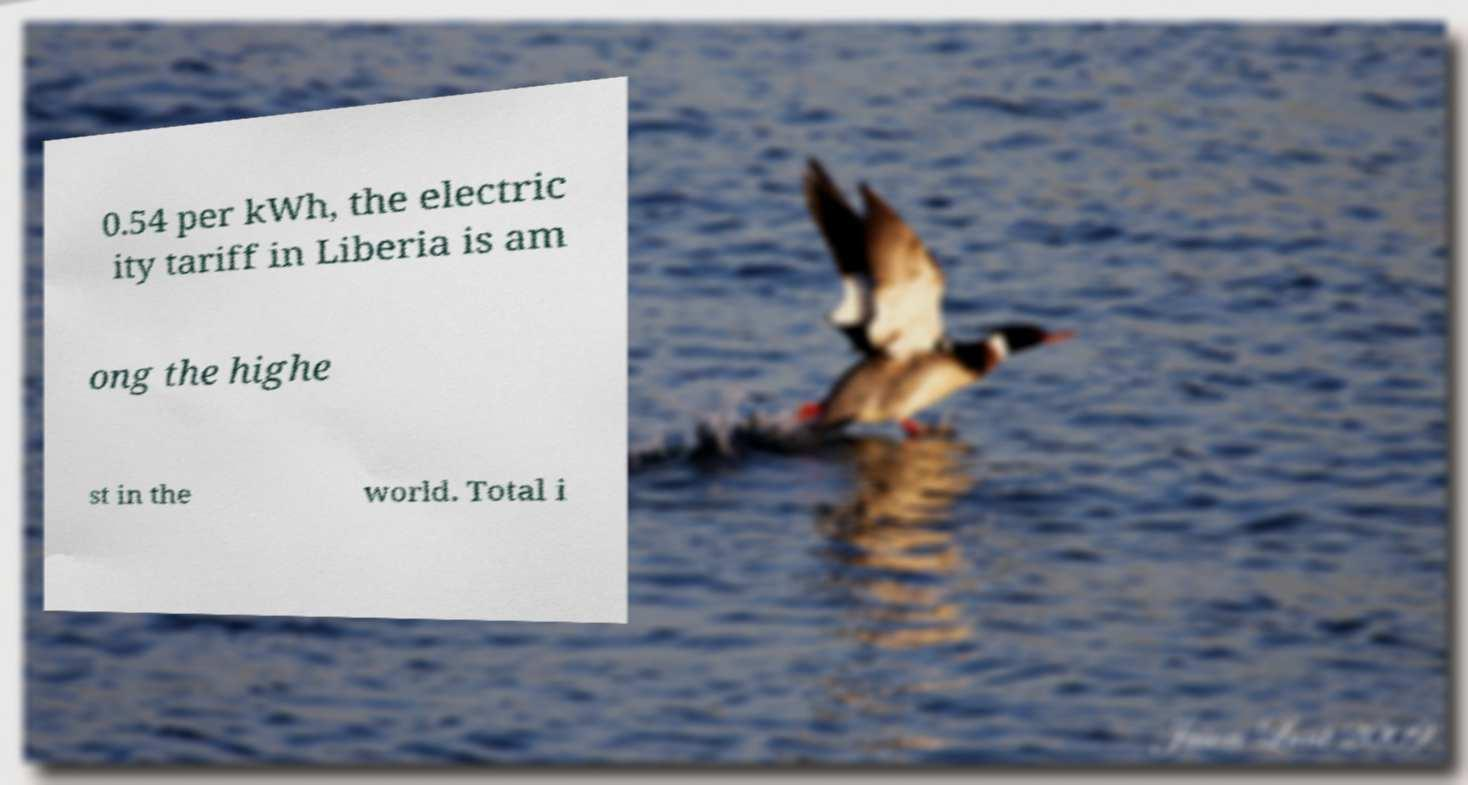Can you read and provide the text displayed in the image?This photo seems to have some interesting text. Can you extract and type it out for me? 0.54 per kWh, the electric ity tariff in Liberia is am ong the highe st in the world. Total i 